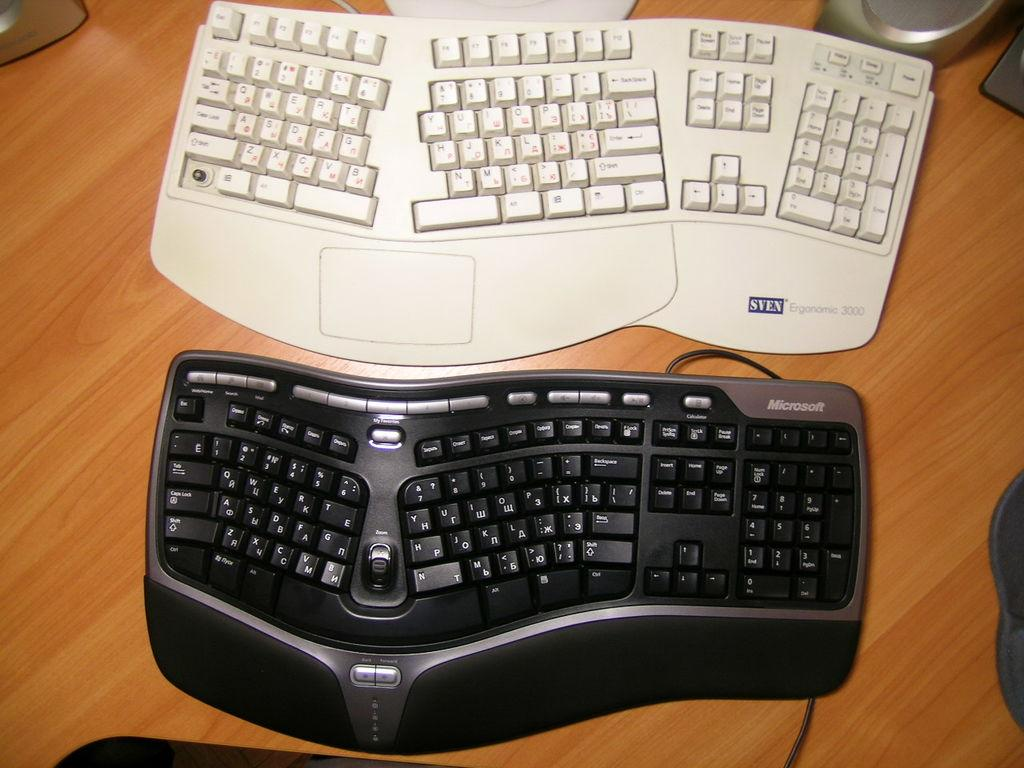<image>
Summarize the visual content of the image. Two keyboards next to one another with one that says SVEN on it. 